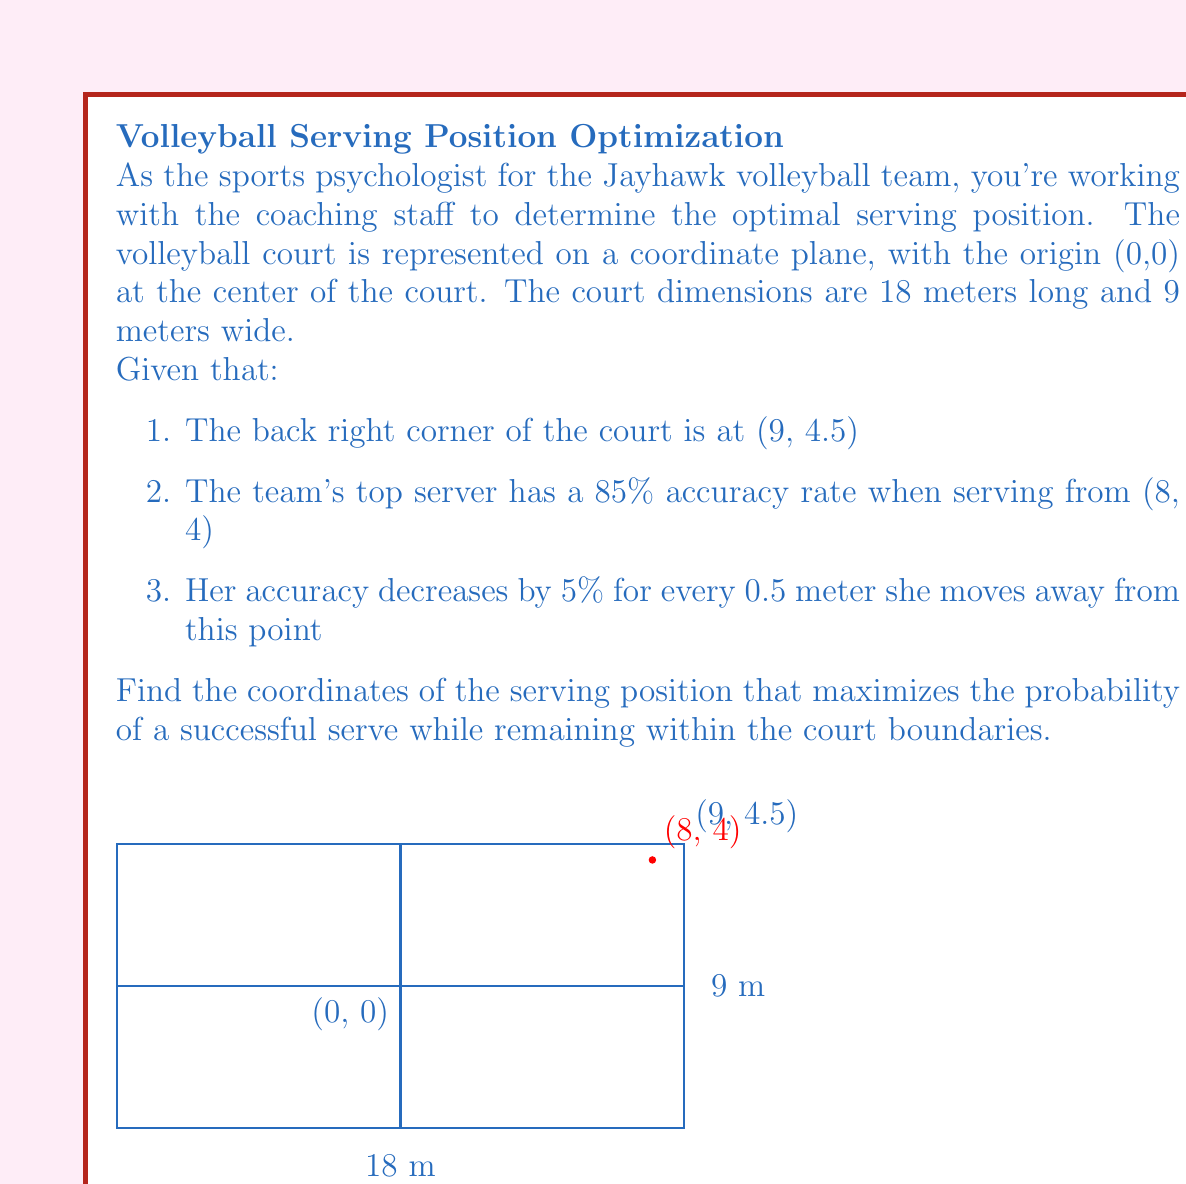Can you answer this question? Let's approach this step-by-step:

1) First, we need to define the function for the server's accuracy based on the distance from the optimal point (8, 4):

   $A(x,y) = 0.85 - 0.1\sqrt{(x-8)^2 + (y-4)^2}$

   Where 0.85 is the 85% accuracy at (8, 4), and 0.1 is the 5% decrease per 0.5 meters (which is 10% per meter).

2) We need to maximize this function within the court boundaries:
   $0 \leq x \leq 9$ and $-4.5 \leq y \leq 4.5$

3) To find the maximum, we could use calculus, but given the constraints, we can deduce that the maximum will occur at (8, 4) or at the nearest point on the boundary if (8, 4) is outside the court.

4) Checking the point (8, 4):
   - x-coordinate (8) is within bounds (0 ≤ 8 ≤ 9)
   - y-coordinate (4) is within bounds (-4.5 ≤ 4 ≤ 4.5)

5) Therefore, (8, 4) is within the court boundaries and is the point of maximum accuracy.

6) The accuracy at this point is 85%, which is higher than any other point in the court (as moving away decreases accuracy).

Thus, the optimal serving position is at the coordinates (8, 4).
Answer: (8, 4) 